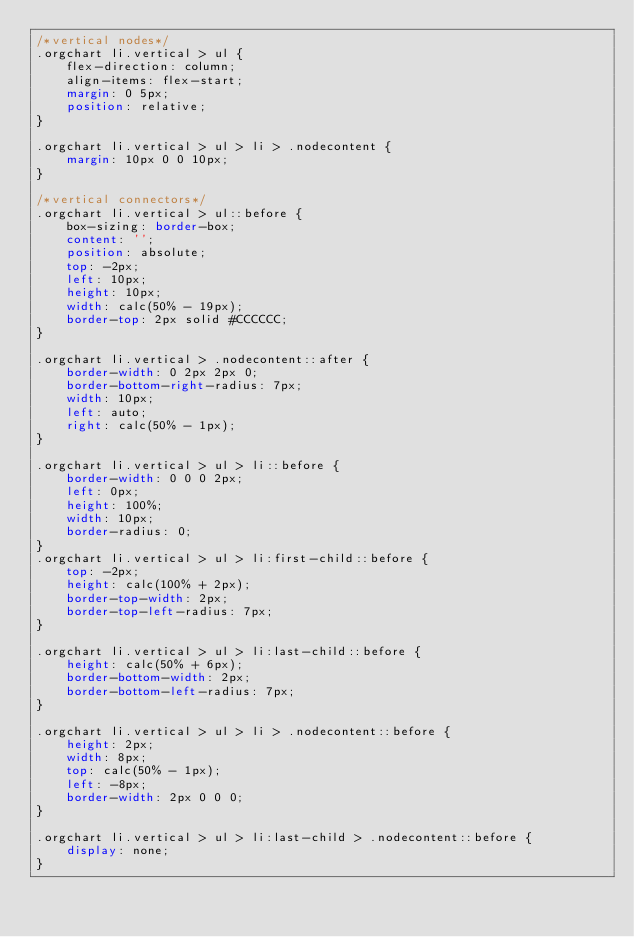Convert code to text. <code><loc_0><loc_0><loc_500><loc_500><_CSS_>/*vertical nodes*/
.orgchart li.vertical > ul {
    flex-direction: column;
    align-items: flex-start;
    margin: 0 5px;
    position: relative;
}

.orgchart li.vertical > ul > li > .nodecontent {
    margin: 10px 0 0 10px;
}

/*vertical connectors*/
.orgchart li.vertical > ul::before {
    box-sizing: border-box;
    content: '';
    position: absolute;
    top: -2px;
    left: 10px;
    height: 10px;
    width: calc(50% - 19px);
    border-top: 2px solid #CCCCCC;
}

.orgchart li.vertical > .nodecontent::after {
    border-width: 0 2px 2px 0;
    border-bottom-right-radius: 7px;
    width: 10px;
    left: auto;
    right: calc(50% - 1px);
}

.orgchart li.vertical > ul > li::before {
    border-width: 0 0 0 2px;
    left: 0px;
    height: 100%;
    width: 10px;
    border-radius: 0;
}
.orgchart li.vertical > ul > li:first-child::before {
    top: -2px;
    height: calc(100% + 2px);
    border-top-width: 2px;
    border-top-left-radius: 7px;
}

.orgchart li.vertical > ul > li:last-child::before {
    height: calc(50% + 6px);
    border-bottom-width: 2px;
    border-bottom-left-radius: 7px;
}

.orgchart li.vertical > ul > li > .nodecontent::before {
    height: 2px;
    width: 8px;
    top: calc(50% - 1px);
    left: -8px;
    border-width: 2px 0 0 0;
}

.orgchart li.vertical > ul > li:last-child > .nodecontent::before {
    display: none;
}
</code> 